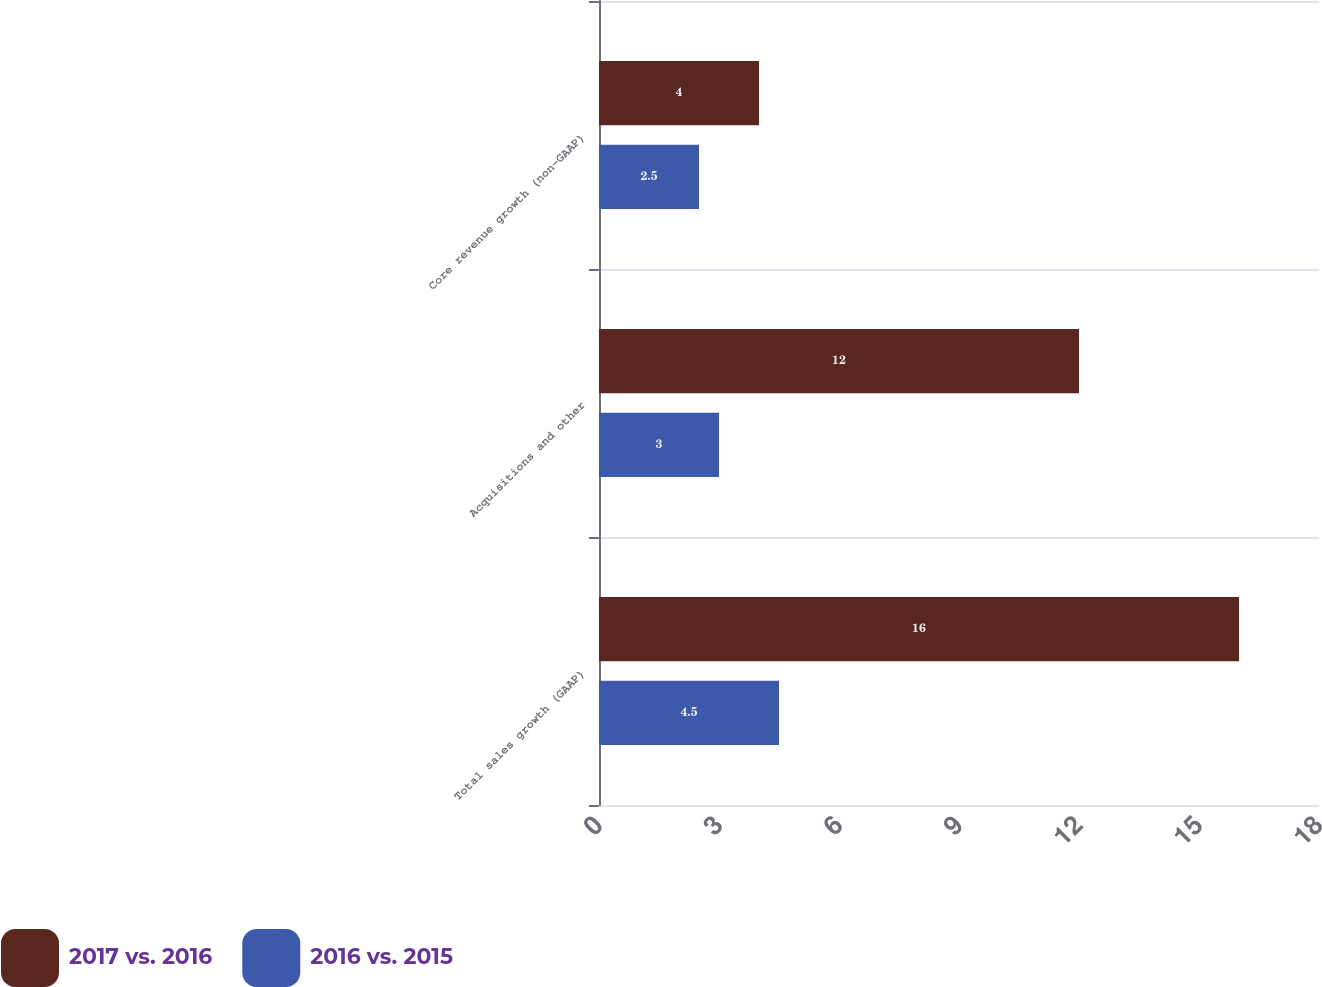<chart> <loc_0><loc_0><loc_500><loc_500><stacked_bar_chart><ecel><fcel>Total sales growth (GAAP)<fcel>Acquisitions and other<fcel>Core revenue growth (non-GAAP)<nl><fcel>2017 vs. 2016<fcel>16<fcel>12<fcel>4<nl><fcel>2016 vs. 2015<fcel>4.5<fcel>3<fcel>2.5<nl></chart> 